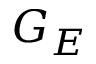<formula> <loc_0><loc_0><loc_500><loc_500>G _ { E }</formula> 